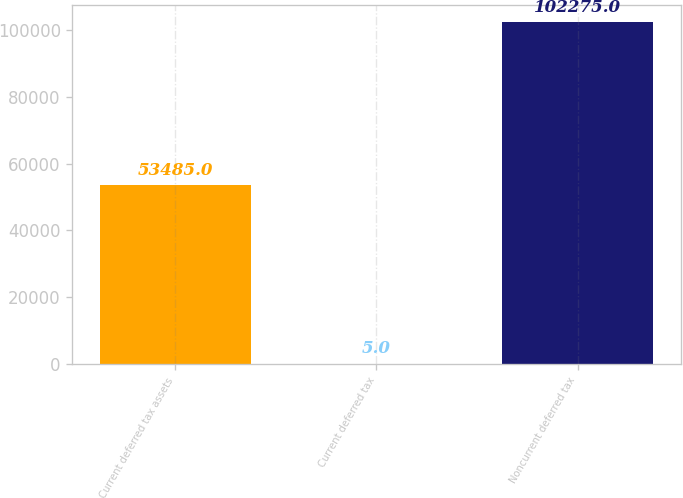<chart> <loc_0><loc_0><loc_500><loc_500><bar_chart><fcel>Current deferred tax assets<fcel>Current deferred tax<fcel>Noncurrent deferred tax<nl><fcel>53485<fcel>5<fcel>102275<nl></chart> 